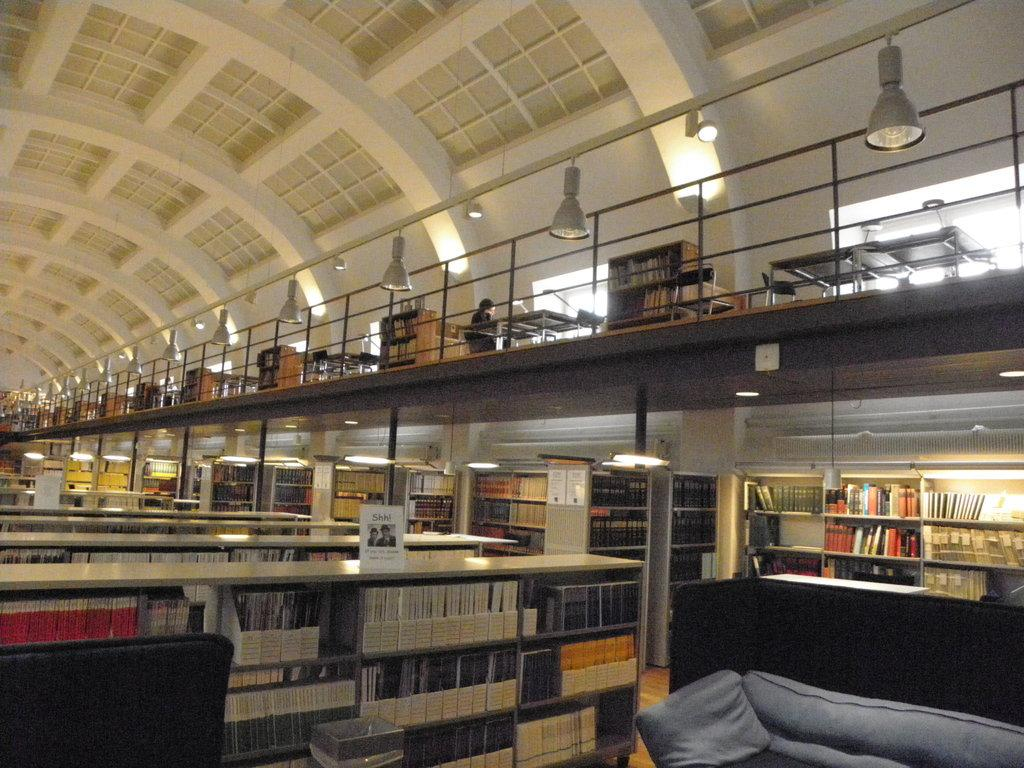What can be found on the shelves in the image? There are books in the shelves. What is the person in the image doing? The person is sitting on a chair. What is hanging on the rack in the image? There is a picture on a rack. What piece of furniture is present in the image? There is a desk in the image. What can be seen providing illumination in the image? There are lights visible in the image. What type of oatmeal is the person eating in the image? There is no oatmeal present in the image; the person is sitting on a chair. How does the sheep react to the picture on the rack in the image? There is no sheep present in the image, so it cannot react to the picture on the rack. 